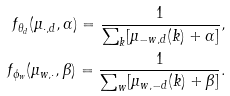Convert formula to latex. <formula><loc_0><loc_0><loc_500><loc_500>f _ { \theta _ { d } } ( \mu _ { \cdot , d } , \alpha ) = \frac { 1 } { \sum _ { k } [ \mu _ { - w , d } ( k ) + \alpha ] } , \\ f _ { \phi _ { w } } ( \mu _ { w , \cdot } , \beta ) = \frac { 1 } { \sum _ { w } [ \mu _ { w , - d } ( k ) + \beta ] } .</formula> 